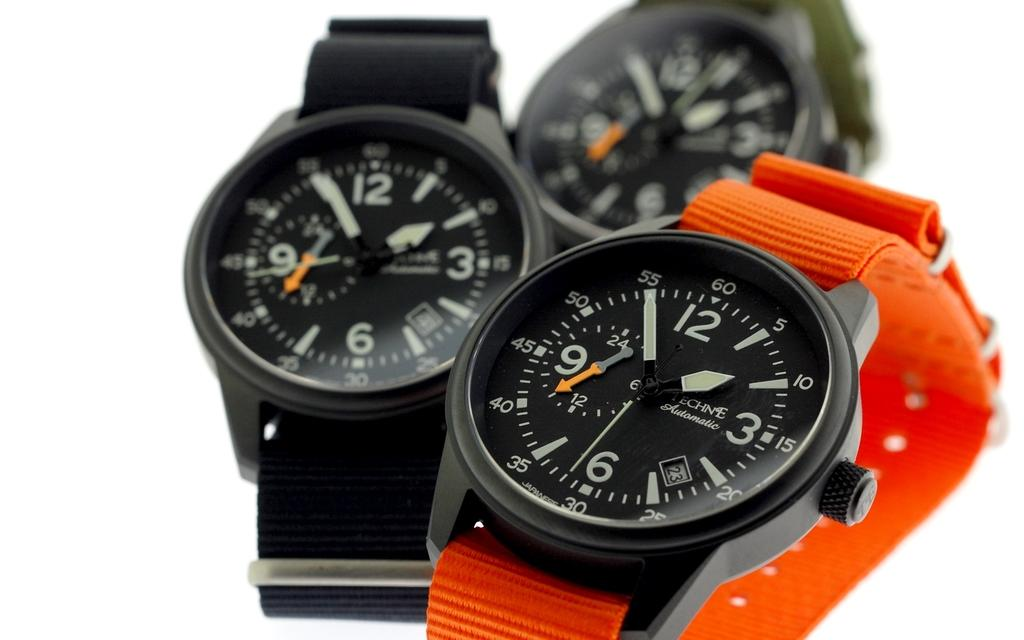<image>
Relay a brief, clear account of the picture shown. Three different colored Penche brand watches are on display. 